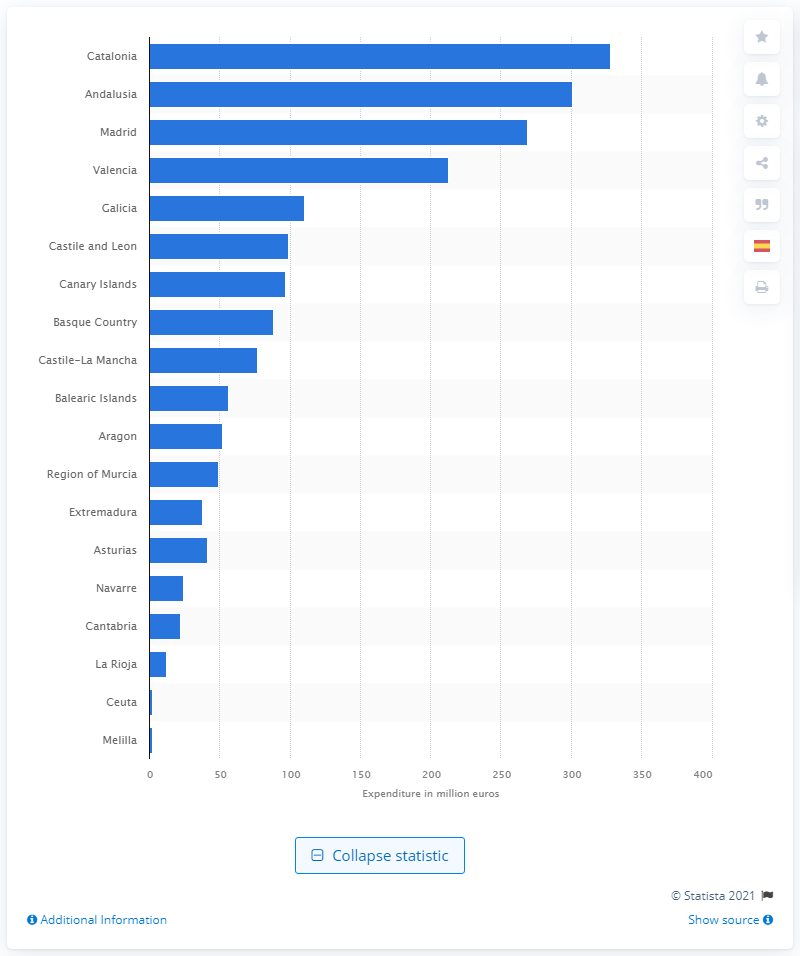Give some essential details in this illustration. The estimated expenditure on tapas and appetizers in Catalonia for 2018 is 328 million. 